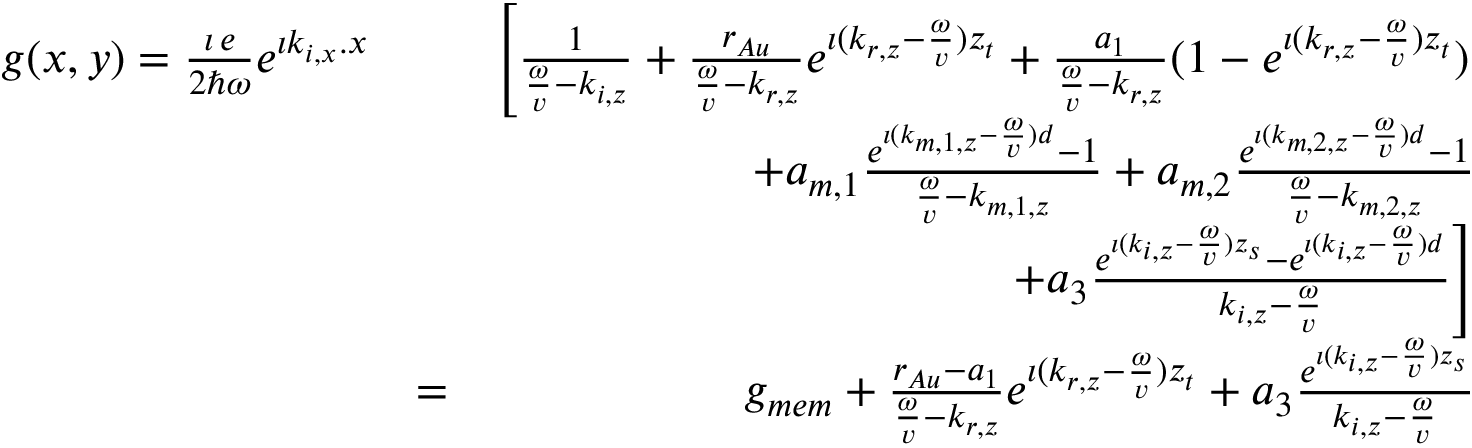Convert formula to latex. <formula><loc_0><loc_0><loc_500><loc_500>\begin{array} { r l r } { g ( x , y ) = \frac { \imath \, e } { 2 \hbar { \omega } } e ^ { \imath k _ { i , x } . x } } & { \left [ \frac { 1 } { \frac { \omega } { v } - k _ { i , z } } + \frac { r _ { A u } } { \frac { \omega } { v } - k _ { r , z } } e ^ { \imath ( k _ { r , z } - \frac { \omega } { v } ) z _ { t } } + \frac { a _ { 1 } } { \frac { \omega } { v } - k _ { r , z } } ( 1 - e ^ { \imath ( k _ { r , z } - \frac { \omega } { v } ) z _ { t } } ) } \\ & { + a _ { m , 1 } \frac { e ^ { \imath ( k _ { m , 1 , z } - \frac { \omega } { v } ) d } - 1 } { \frac { \omega } { v } - k _ { m , 1 , z } } + a _ { m , 2 } \frac { e ^ { \imath ( k _ { m , 2 , z } - \frac { \omega } { v } ) d } - 1 } { \frac { \omega } { v } - k _ { m , 2 , z } } } \\ & { + a _ { 3 } \frac { e ^ { \imath ( k _ { i , z } - \frac { \omega } { v } ) z _ { s } } - e ^ { \imath ( k _ { i , z } - \frac { \omega } { v } ) d } } { k _ { i , z } - \frac { \omega } { v } } \right ] } \\ & { = } & { g _ { m e m } + \frac { r _ { A u } - a _ { 1 } } { \frac { \omega } { v } - k _ { r , z } } e ^ { \imath ( k _ { r , z } - \frac { \omega } { v } ) z _ { t } } + a _ { 3 } \frac { e ^ { \imath ( k _ { i , z } - \frac { \omega } { v } ) z _ { s } } } { k _ { i , z } - \frac { \omega } { v } } } \end{array}</formula> 